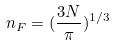<formula> <loc_0><loc_0><loc_500><loc_500>n _ { F } = ( \frac { 3 N } { \pi } ) ^ { 1 / 3 }</formula> 